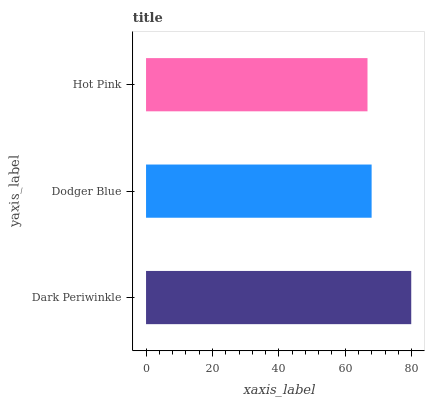Is Hot Pink the minimum?
Answer yes or no. Yes. Is Dark Periwinkle the maximum?
Answer yes or no. Yes. Is Dodger Blue the minimum?
Answer yes or no. No. Is Dodger Blue the maximum?
Answer yes or no. No. Is Dark Periwinkle greater than Dodger Blue?
Answer yes or no. Yes. Is Dodger Blue less than Dark Periwinkle?
Answer yes or no. Yes. Is Dodger Blue greater than Dark Periwinkle?
Answer yes or no. No. Is Dark Periwinkle less than Dodger Blue?
Answer yes or no. No. Is Dodger Blue the high median?
Answer yes or no. Yes. Is Dodger Blue the low median?
Answer yes or no. Yes. Is Hot Pink the high median?
Answer yes or no. No. Is Dark Periwinkle the low median?
Answer yes or no. No. 